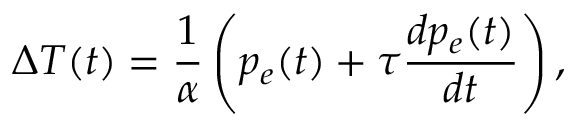Convert formula to latex. <formula><loc_0><loc_0><loc_500><loc_500>\Delta T ( t ) = \frac { 1 } { \alpha } \left ( p _ { e } ( t ) + \tau \frac { d p _ { e } ( t ) } { d t } \right ) ,</formula> 